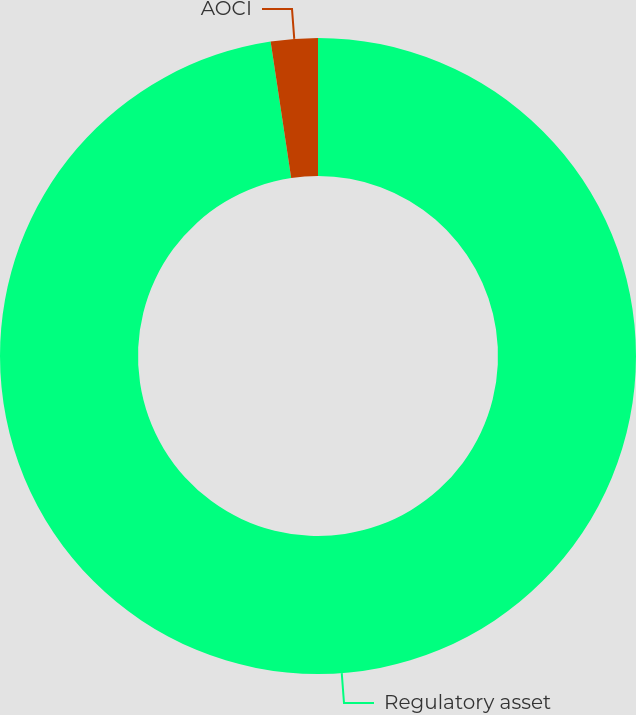Convert chart to OTSL. <chart><loc_0><loc_0><loc_500><loc_500><pie_chart><fcel>Regulatory asset<fcel>AOCI<nl><fcel>97.62%<fcel>2.38%<nl></chart> 